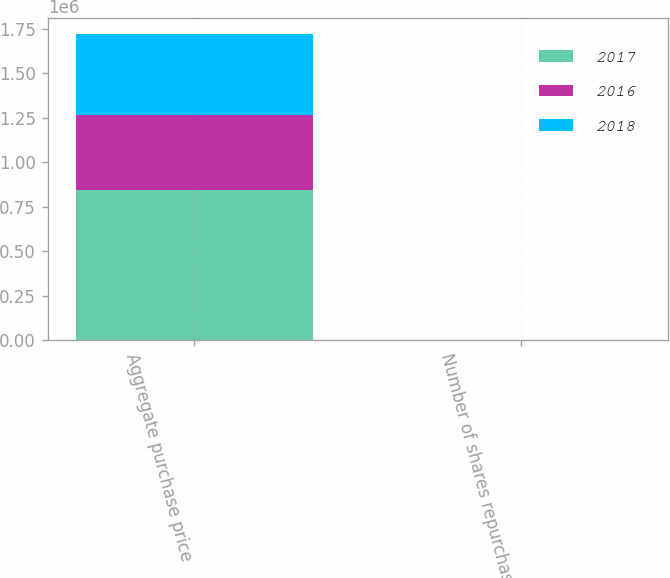Convert chart to OTSL. <chart><loc_0><loc_0><loc_500><loc_500><stacked_bar_chart><ecel><fcel>Aggregate purchase price<fcel>Number of shares repurchased<nl><fcel>2017<fcel>846134<fcel>301<nl><fcel>2016<fcel>422166<fcel>167<nl><fcel>2018<fcel>455351<fcel>280<nl></chart> 